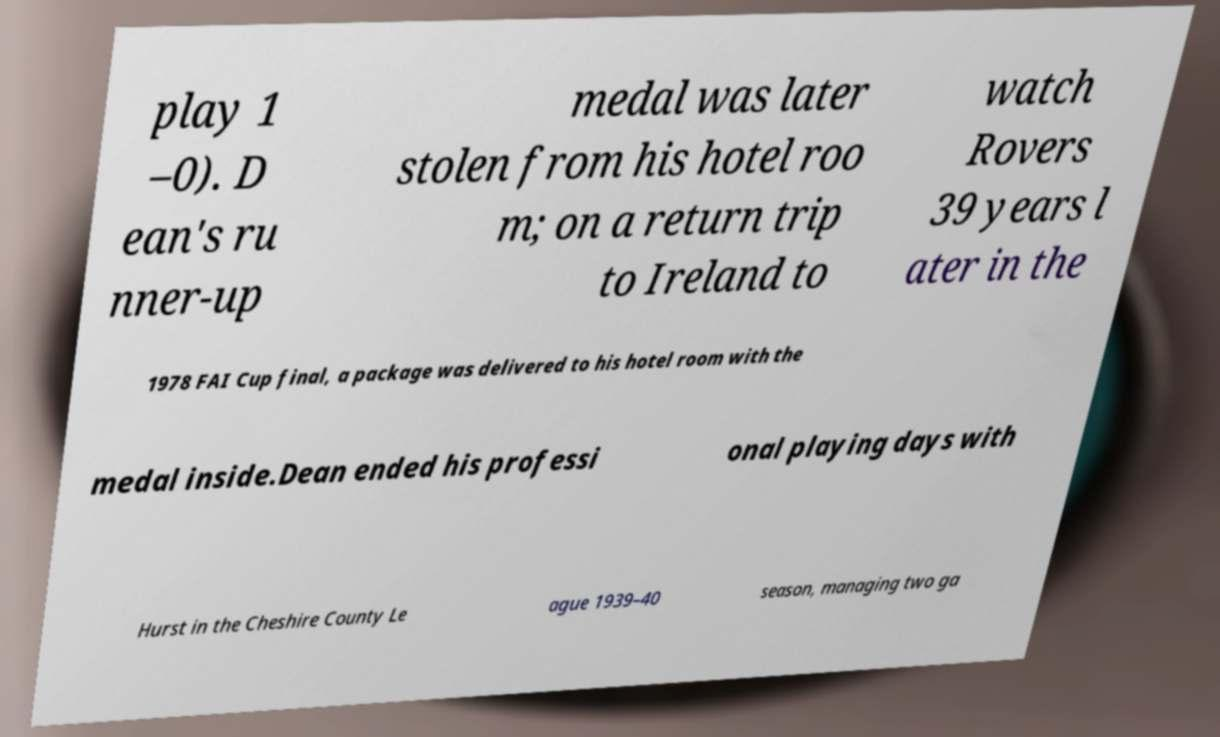There's text embedded in this image that I need extracted. Can you transcribe it verbatim? play 1 –0). D ean's ru nner-up medal was later stolen from his hotel roo m; on a return trip to Ireland to watch Rovers 39 years l ater in the 1978 FAI Cup final, a package was delivered to his hotel room with the medal inside.Dean ended his professi onal playing days with Hurst in the Cheshire County Le ague 1939–40 season, managing two ga 